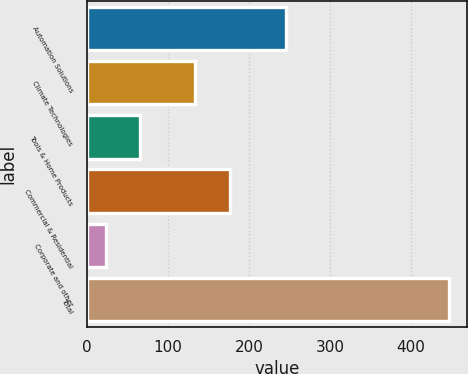<chart> <loc_0><loc_0><loc_500><loc_500><bar_chart><fcel>Automation Solutions<fcel>Climate Technologies<fcel>Tools & Home Products<fcel>Commercial & Residential<fcel>Corporate and other<fcel>Total<nl><fcel>246<fcel>133<fcel>66.3<fcel>177<fcel>24<fcel>447<nl></chart> 